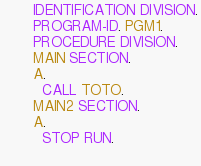Convert code to text. <code><loc_0><loc_0><loc_500><loc_500><_COBOL_>       IDENTIFICATION DIVISION.
       PROGRAM-ID. PGM1.
       PROCEDURE DIVISION.
       MAIN SECTION.
       A.
         CALL TOTO.
       MAIN2 SECTION.
       A.
         STOP RUN.
         
</code> 